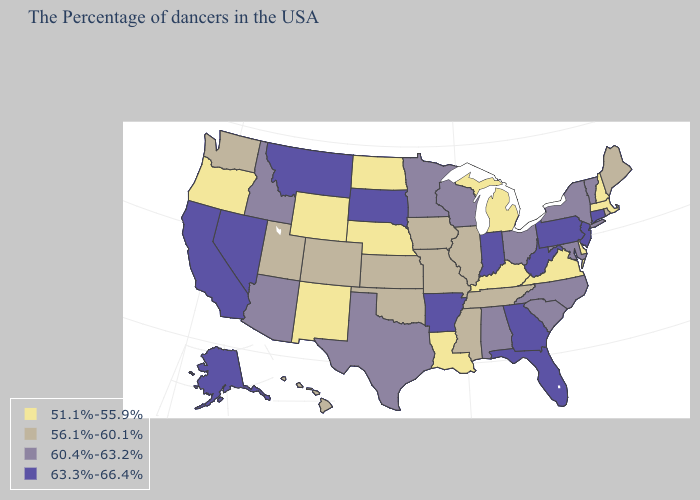What is the value of Arizona?
Give a very brief answer. 60.4%-63.2%. Name the states that have a value in the range 56.1%-60.1%?
Short answer required. Maine, Rhode Island, Tennessee, Illinois, Mississippi, Missouri, Iowa, Kansas, Oklahoma, Colorado, Utah, Washington, Hawaii. Which states hav the highest value in the West?
Quick response, please. Montana, Nevada, California, Alaska. What is the value of Rhode Island?
Give a very brief answer. 56.1%-60.1%. What is the value of Wyoming?
Quick response, please. 51.1%-55.9%. Is the legend a continuous bar?
Keep it brief. No. Name the states that have a value in the range 60.4%-63.2%?
Write a very short answer. Vermont, New York, Maryland, North Carolina, South Carolina, Ohio, Alabama, Wisconsin, Minnesota, Texas, Arizona, Idaho. Which states have the lowest value in the USA?
Short answer required. Massachusetts, New Hampshire, Delaware, Virginia, Michigan, Kentucky, Louisiana, Nebraska, North Dakota, Wyoming, New Mexico, Oregon. What is the value of Oklahoma?
Concise answer only. 56.1%-60.1%. Does Michigan have the same value as Kansas?
Answer briefly. No. Name the states that have a value in the range 56.1%-60.1%?
Quick response, please. Maine, Rhode Island, Tennessee, Illinois, Mississippi, Missouri, Iowa, Kansas, Oklahoma, Colorado, Utah, Washington, Hawaii. What is the value of New Jersey?
Be succinct. 63.3%-66.4%. Name the states that have a value in the range 56.1%-60.1%?
Short answer required. Maine, Rhode Island, Tennessee, Illinois, Mississippi, Missouri, Iowa, Kansas, Oklahoma, Colorado, Utah, Washington, Hawaii. 